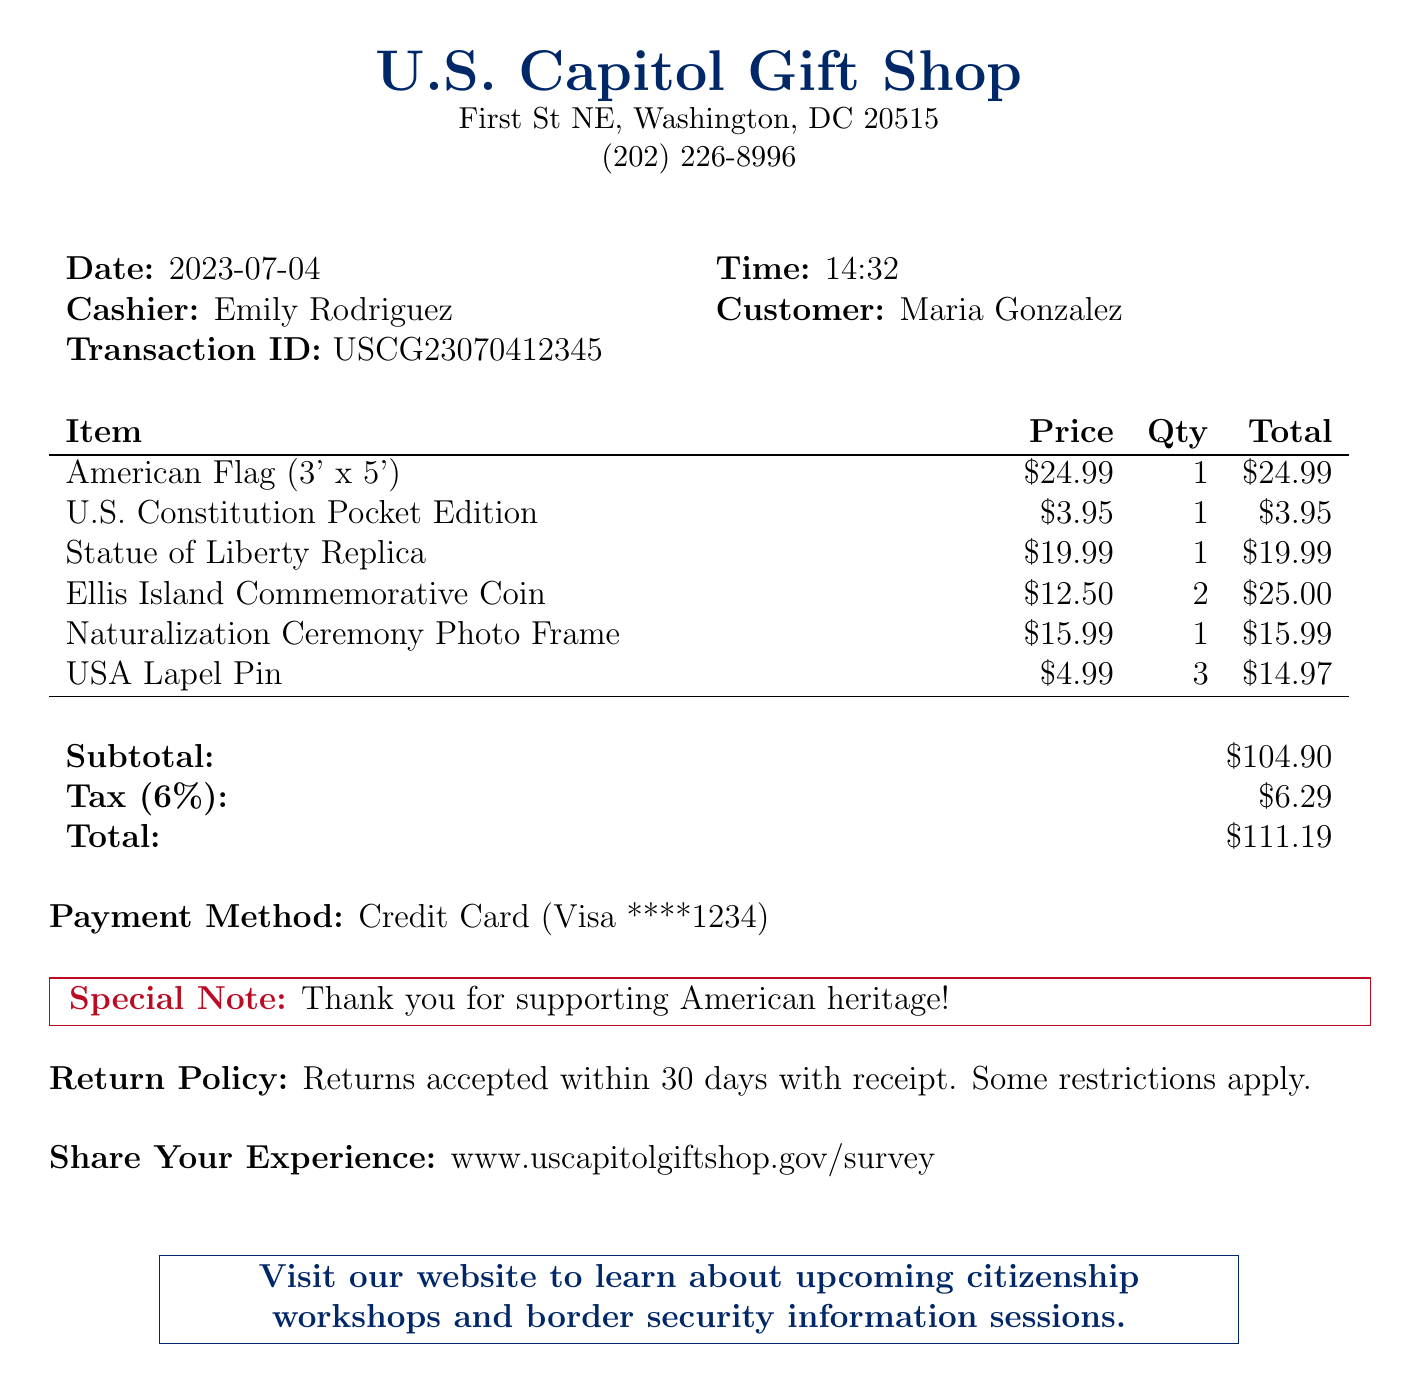What is the name of the store? The store's name is listed at the top of the document.
Answer: U.S. Capitol Gift Shop What was the date of the purchase? The date is clearly marked in the receipt details.
Answer: 2023-07-04 Who was the cashier? The cashier's name is provided alongside the transaction details.
Answer: Emily Rodriguez What is the total amount spent? The total amount is calculated at the end of the receipt.
Answer: $111.19 How many Ellis Island Commemorative Coins were purchased? The quantity of this item is shown in the list of items bought.
Answer: 2 What is the tax amount? The tax amount is specified in the financial summary of the receipt.
Answer: $6.29 What method of payment was used? The payment method is stated near the end of the receipt.
Answer: Credit Card What is the return policy? The return policy is provided at the bottom of the receipt.
Answer: Returns accepted within 30 days with receipt What special note was included? A special note is included as a highlight on the receipt.
Answer: Thank you for supporting American heritage! What information can be learned from the website mentioned? The promotional text suggests specific workshops and sessions.
Answer: Upcoming citizenship workshops and border security information sessions 